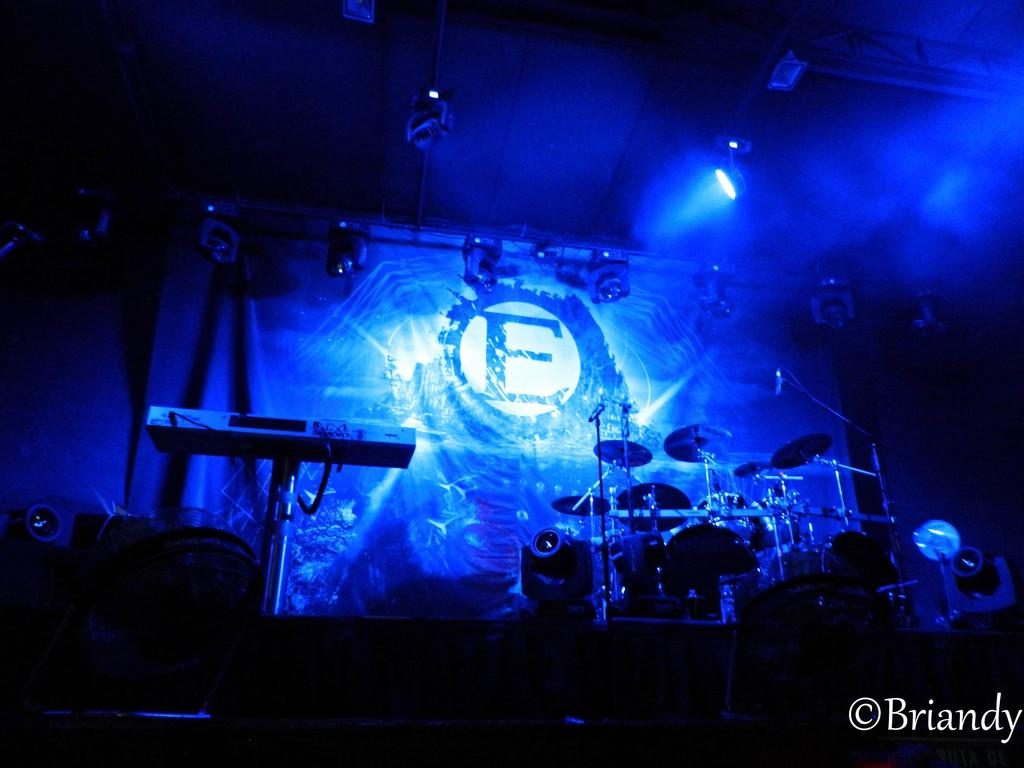What objects can be seen in the image related to music? There are musical instruments in the image. What type of lighting is present in the background of the image? There are electric lights in the background of the image. What architectural feature can be seen in the background of the image? There are iron grills in the background of the image. What type of fabric is present in the background of the image? There is a curtain in the background of the image. Where is the mine located in the image? There is no mine present in the image. How many chickens are visible in the image? There are no chickens present in the image. 